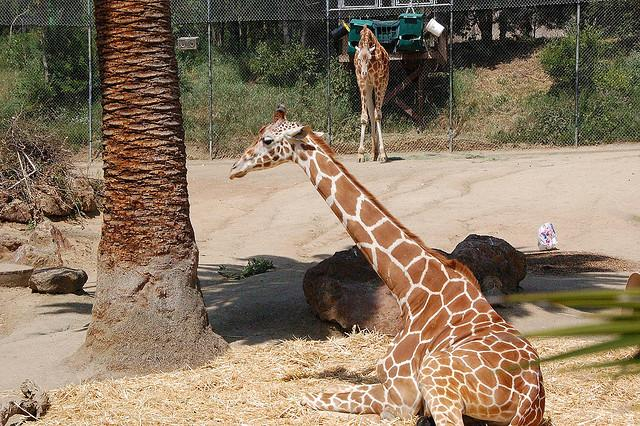What state of mind is the giraffe most likely in? relaxed 